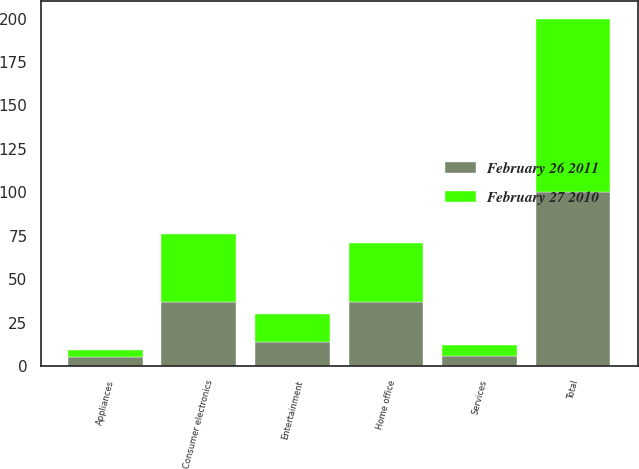Convert chart to OTSL. <chart><loc_0><loc_0><loc_500><loc_500><stacked_bar_chart><ecel><fcel>Consumer electronics<fcel>Home office<fcel>Entertainment<fcel>Appliances<fcel>Services<fcel>Total<nl><fcel>February 26 2011<fcel>37<fcel>37<fcel>14<fcel>5<fcel>6<fcel>100<nl><fcel>February 27 2010<fcel>39<fcel>34<fcel>16<fcel>4<fcel>6<fcel>100<nl></chart> 